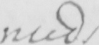Transcribe the text shown in this historical manuscript line. needs 